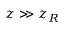Convert formula to latex. <formula><loc_0><loc_0><loc_500><loc_500>z \gg z _ { R }</formula> 